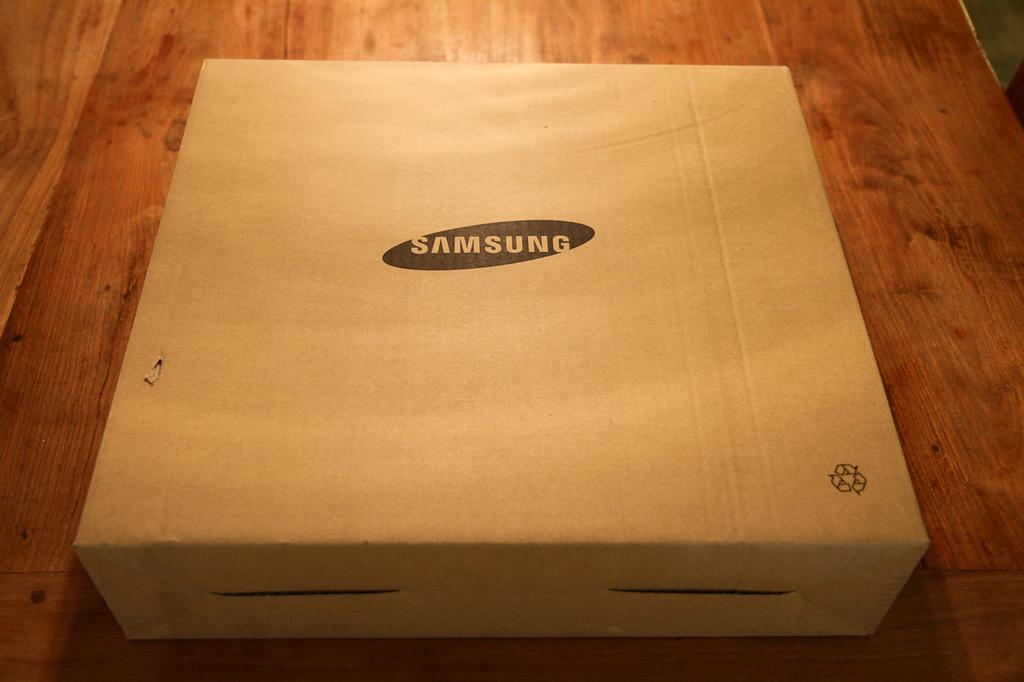Provide a one-sentence caption for the provided image. A box from Samsung that looks like a pizza box but smaller. 